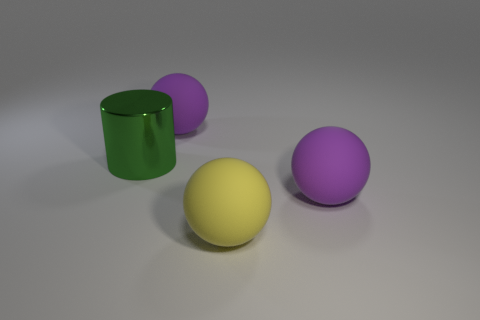What could be the purpose of these objects? The objects in the image look like simple geometric shapes that could serve educational purposes, such as teaching about shapes, colors, and spatial relationships. They could also be part of a set of toys designed to encourage creativity and tactile exploration, or possibly elements in a larger decorative arrangement. 